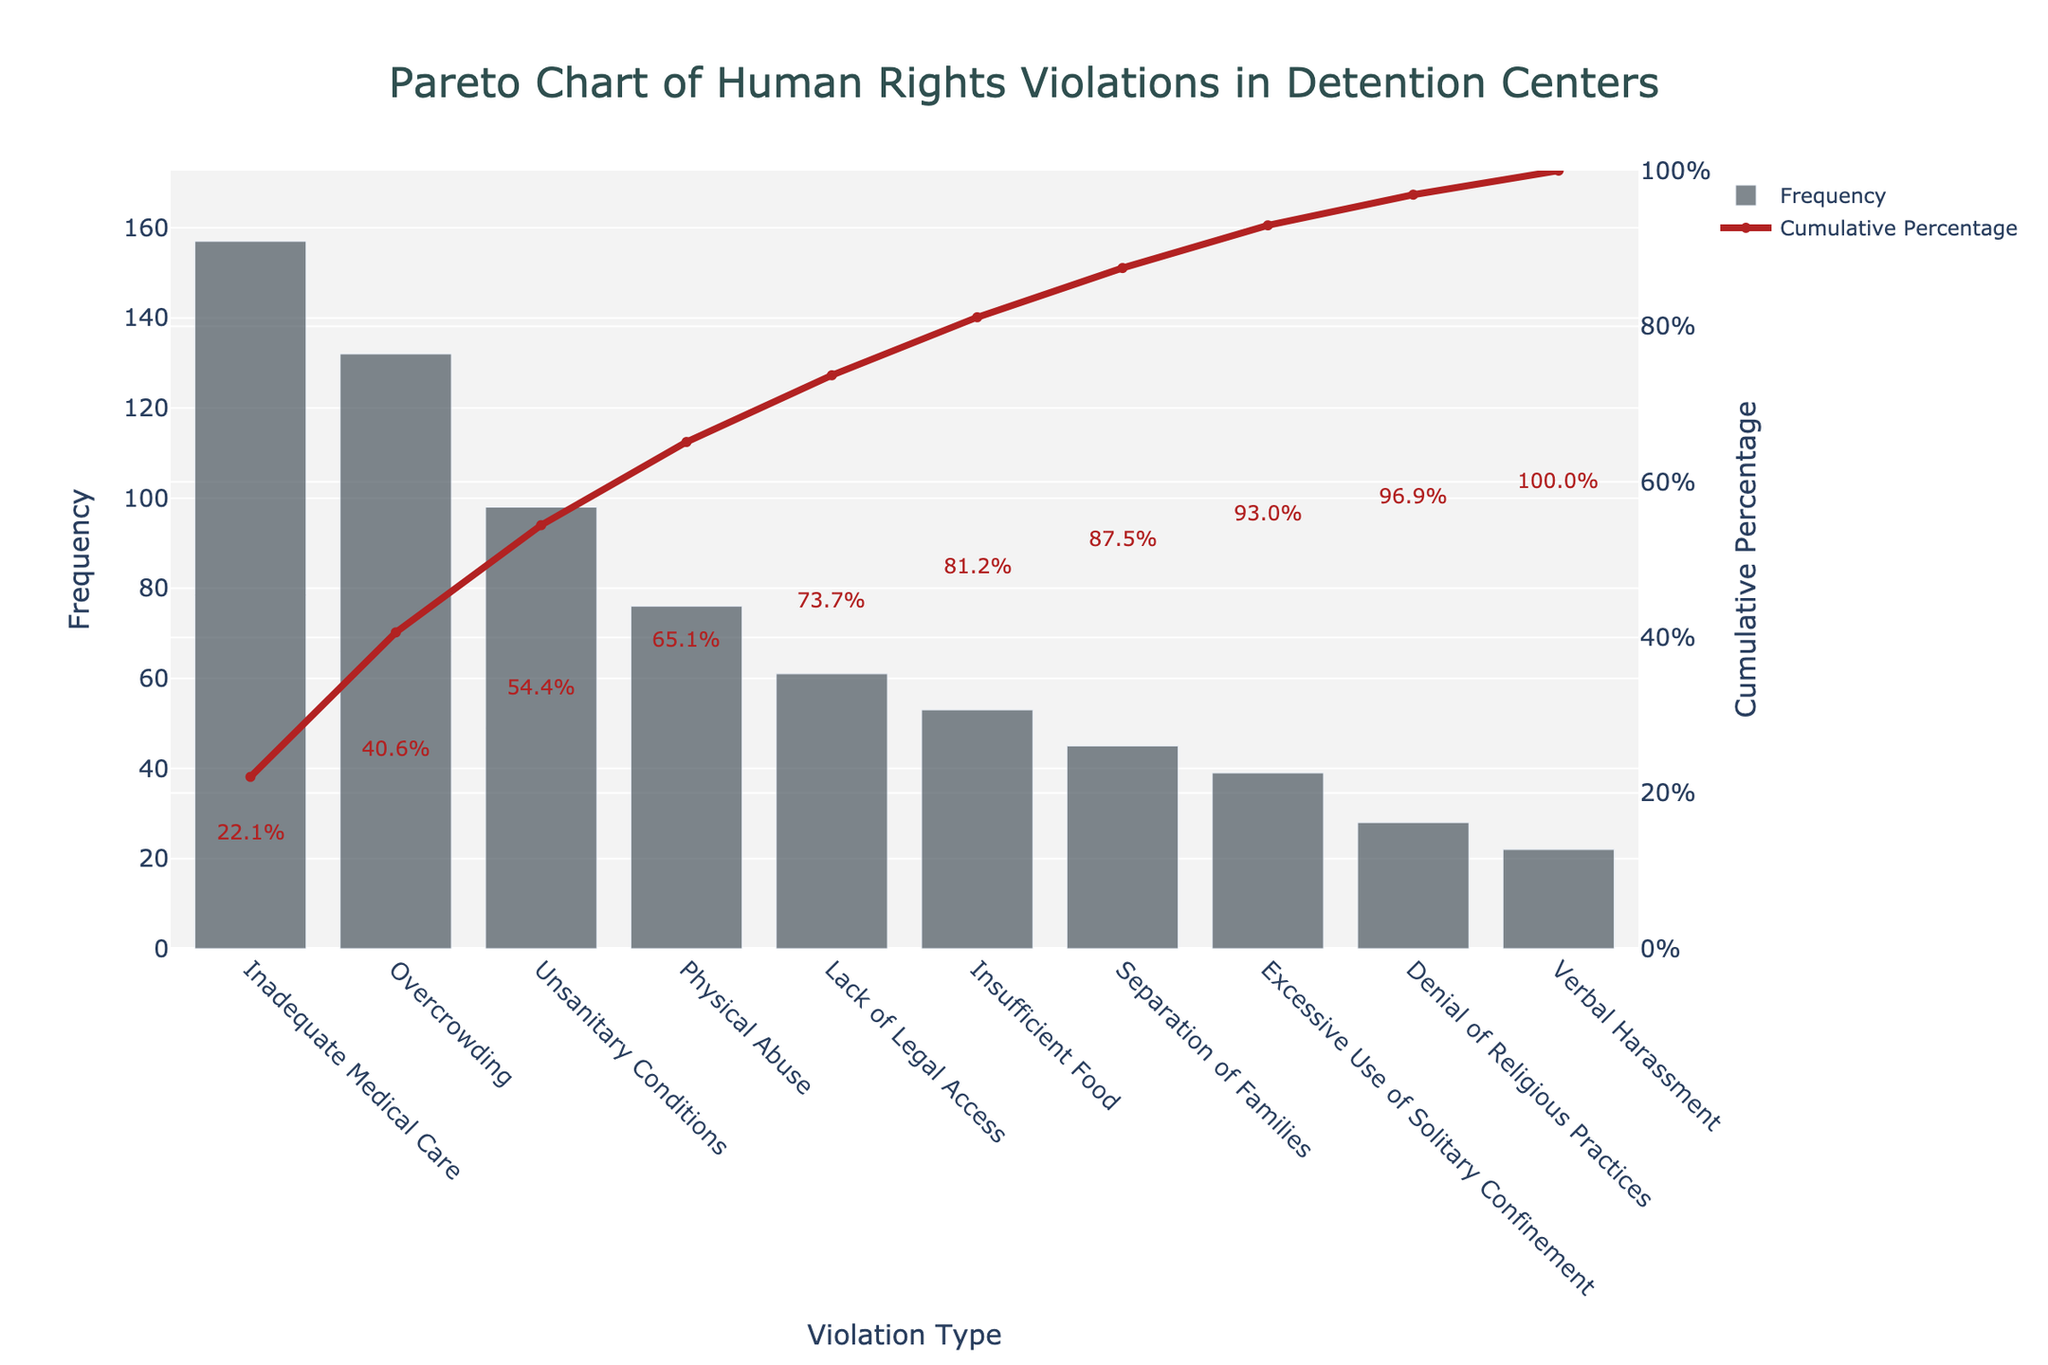What's the title of the chart? The title of the chart is usually displayed at the top and summarizes the main takeaway or topic of the visual data. In this case, the title is "Pareto Chart of Human Rights Violations in Detention Centers"
Answer: Pareto Chart of Human Rights Violations in Detention Centers Which violation type has the highest frequency? The bar element with the highest value represents the violation type with the highest frequency. From the figure, it is "Inadequate Medical Care" with a frequency of 157.
Answer: Inadequate Medical Care What is the total frequency of all documented human rights violations combined? Sum all the frequencies of listed violation types: 157 + 132 + 98 + 76 + 61 + 53 + 45 + 39 + 28 + 22 = 711. Therefore, the total frequency is 711.
Answer: 711 What is the cumulative percentage after the first four violation types? Sum the frequencies of the first four types: 157 (Inadequate Medical Care) + 132 (Overcrowding) + 98 (Unsanitary Conditions) + 76 (Physical Abuse) = 463. Calculate the cumulative percentage: (463 / 711) * 100 ≈ 65.11%.
Answer: 65.1% Which violation type has a frequency closest to the median value of all the frequencies? List all frequencies in ascending order: 22, 28, 39, 45, 53, 61, 76, 98, 132, 157. The median is the average of the 5th and 6th values: (53 + 61) / 2 = 57. The closest type to 57 is "Insufficient Food" with a frequency of 53.
Answer: Insufficient Food What is the frequency difference between the most frequent and least frequent violation types? The most frequent type is "Inadequate Medical Care" with 157, and the least frequent is "Verbal Harassment" with 22. The difference is 157 - 22 = 135.
Answer: 135 How many violation types make up more than 50% of the total frequency? First, find 50% of the total frequency: 0.5 * 711 ≈ 355.5. Sum the frequencies in descending order until the sum exceeds 355.5. 157 (Inadequate Medical Care) + 132 (Overcrowding) + 98 (Unsanitary Conditions) = 387. These 3 types constitute more than 50%.
Answer: 3 At which violation type does the cumulative percentage cross 80%? Add cumulative frequencies until they cross 80% of the total frequency: (Inadequate Medical Care + Overcrowding + Unsanitary Conditions + Physical Abuse + Lack of Legal Access) = 157 + 132 + 98 + 76 + 61 = 524. Cumulative percentage of 524/711 ≈ 73.68%. Adding Insufficient Food's frequency: 524 + 53 = 577, which has cumulative percentage 577/711 ≈ 81.2%. This means at "Insufficient Food" cumulative percentage crosses 80%.
Answer: Insufficient Food 